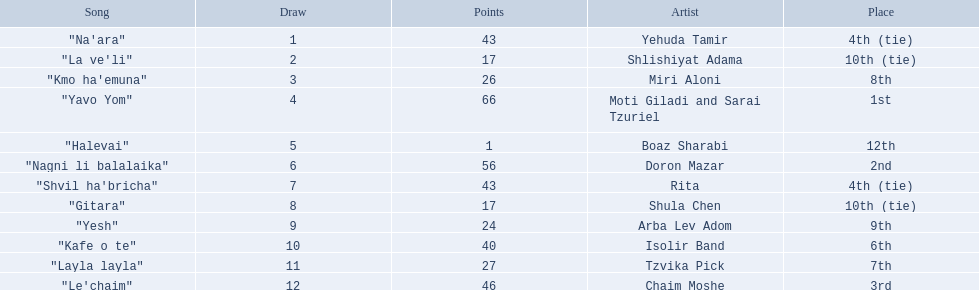What are the points in the competition? 43, 17, 26, 66, 1, 56, 43, 17, 24, 40, 27, 46. What is the lowest points? 1. What artist received these points? Boaz Sharabi. 